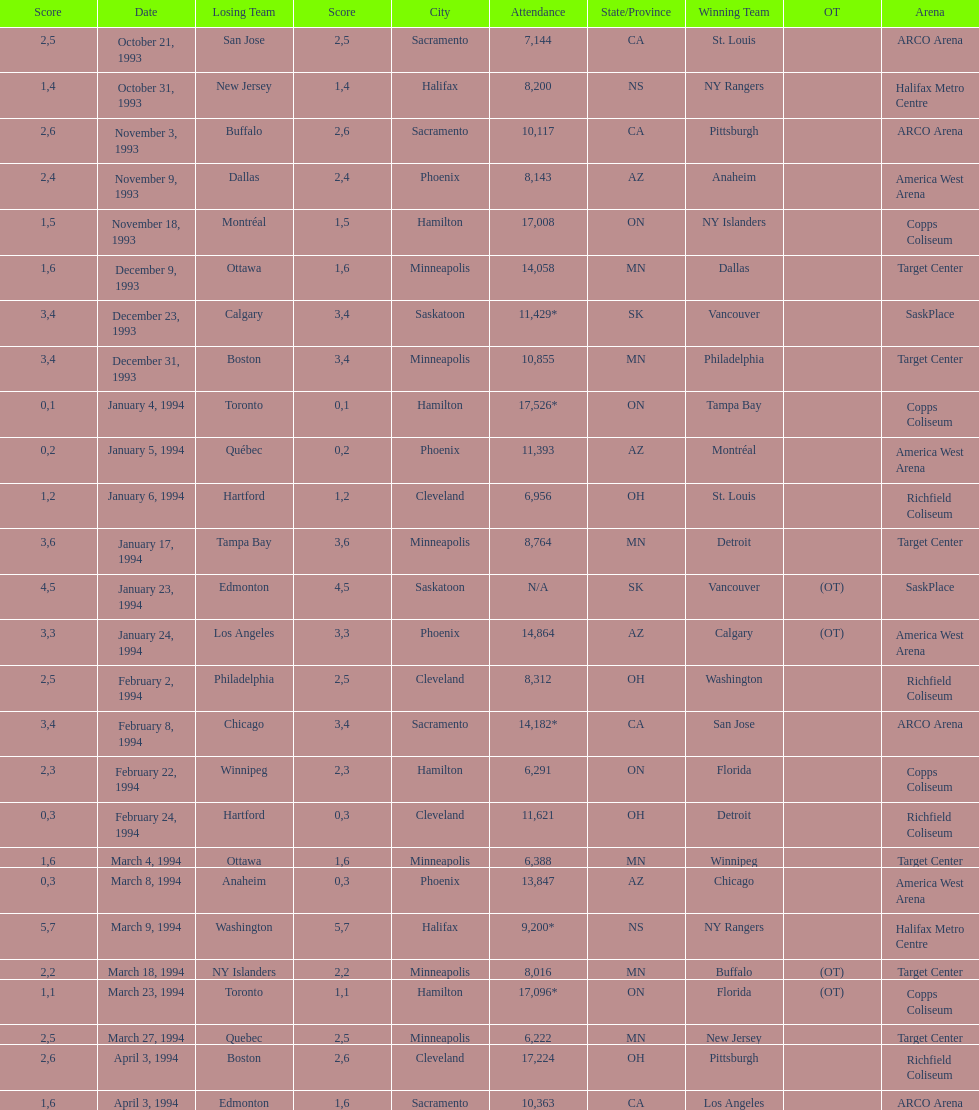How many more people attended the november 18, 1993 games than the november 9th game? 8865. 